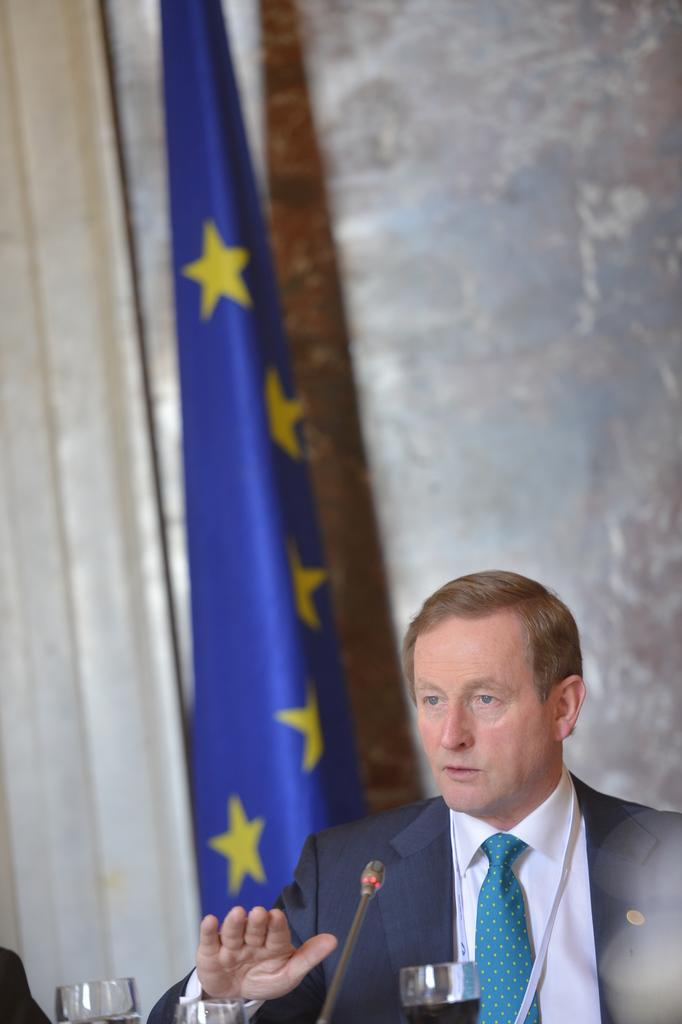Who is present in the image? There is a man in the image. What is the man wearing that is related to his eyes? The man is wearing glasses with liquid. What object is visible that is commonly used for amplifying sound? There is a microphone in the image. What can be seen in the background of the image? There is a flag, a curtain, and a wall in the background of the image. What type of egg is being used as a prop in the image? There is no egg present in the image. What is the man's reason for being in the image? The image does not provide information about the man's reason for being there. 